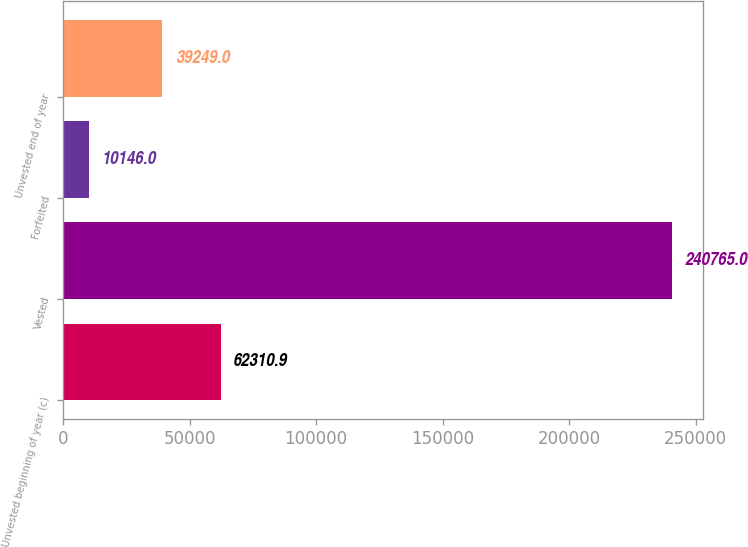Convert chart. <chart><loc_0><loc_0><loc_500><loc_500><bar_chart><fcel>Unvested beginning of year (c)<fcel>Vested<fcel>Forfeited<fcel>Unvested end of year<nl><fcel>62310.9<fcel>240765<fcel>10146<fcel>39249<nl></chart> 